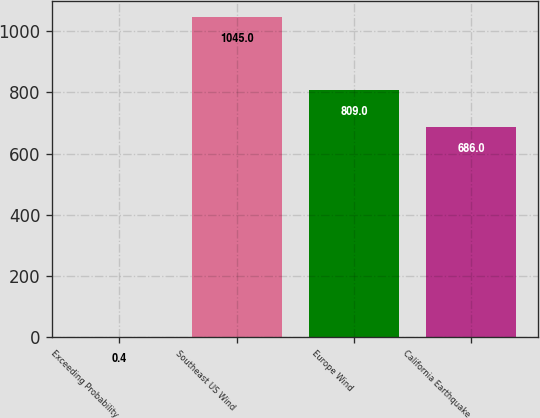Convert chart to OTSL. <chart><loc_0><loc_0><loc_500><loc_500><bar_chart><fcel>Exceeding Probability<fcel>Southeast US Wind<fcel>Europe Wind<fcel>California Earthquake<nl><fcel>0.4<fcel>1045<fcel>809<fcel>686<nl></chart> 